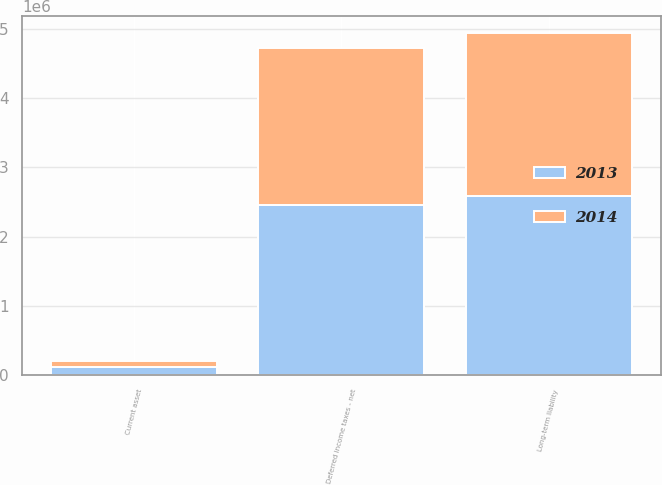Convert chart to OTSL. <chart><loc_0><loc_0><loc_500><loc_500><stacked_bar_chart><ecel><fcel>Current asset<fcel>Long-term liability<fcel>Deferred income taxes - net<nl><fcel>2013<fcel>122232<fcel>2.58264e+06<fcel>2.4604e+06<nl><fcel>2014<fcel>91152<fcel>2.35188e+06<fcel>2.26073e+06<nl></chart> 